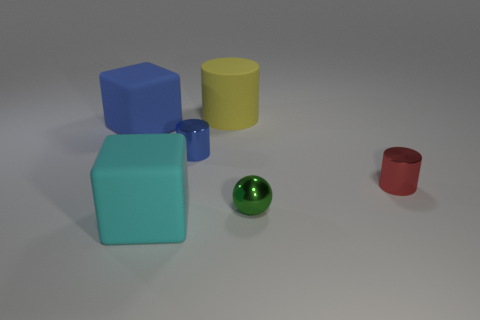Is there any pattern or uniformity in how the objects are arranged? The objects are arranged seemingly at random without any evident pattern or alignment. Their positions do not suggest any intentional order or design. 